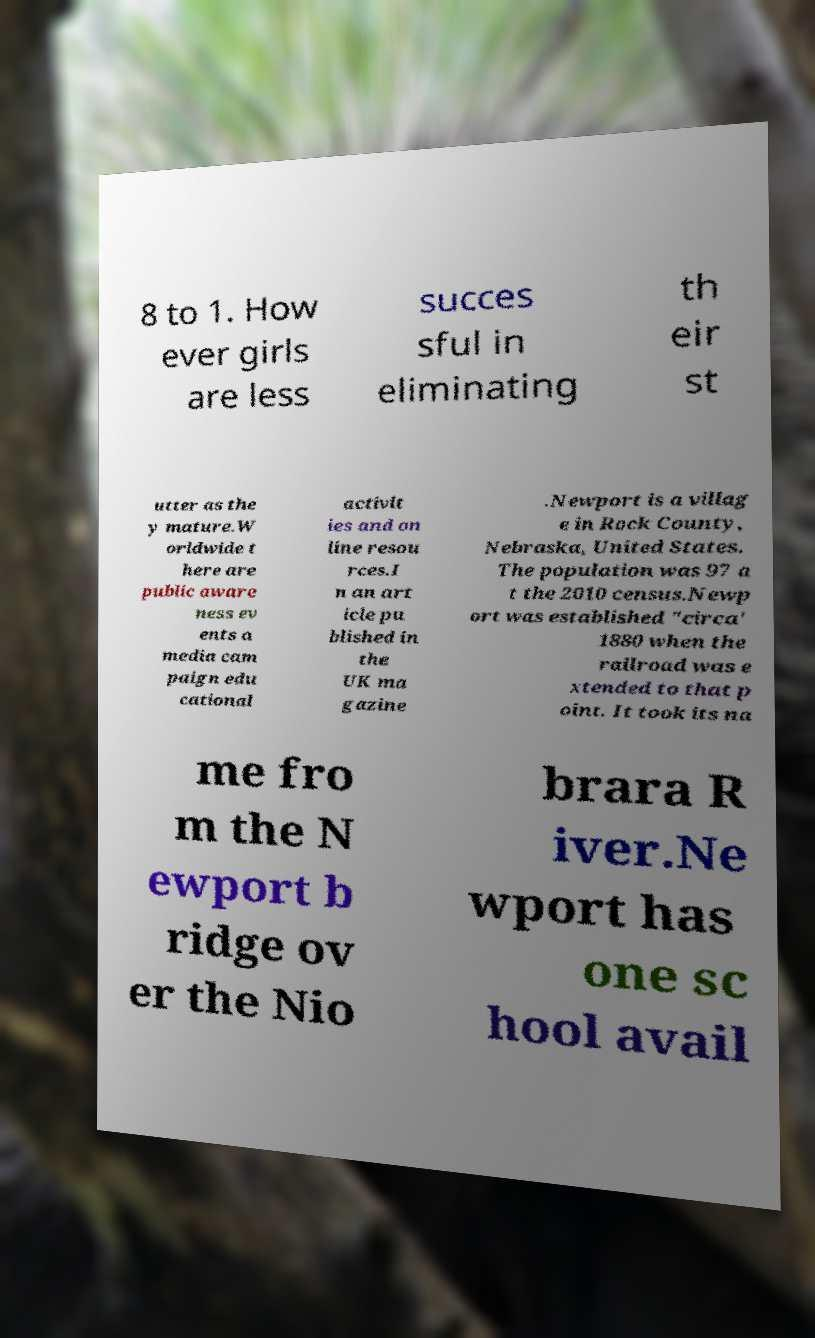For documentation purposes, I need the text within this image transcribed. Could you provide that? 8 to 1. How ever girls are less succes sful in eliminating th eir st utter as the y mature.W orldwide t here are public aware ness ev ents a media cam paign edu cational activit ies and on line resou rces.I n an art icle pu blished in the UK ma gazine .Newport is a villag e in Rock County, Nebraska, United States. The population was 97 a t the 2010 census.Newp ort was established "circa' 1880 when the railroad was e xtended to that p oint. It took its na me fro m the N ewport b ridge ov er the Nio brara R iver.Ne wport has one sc hool avail 